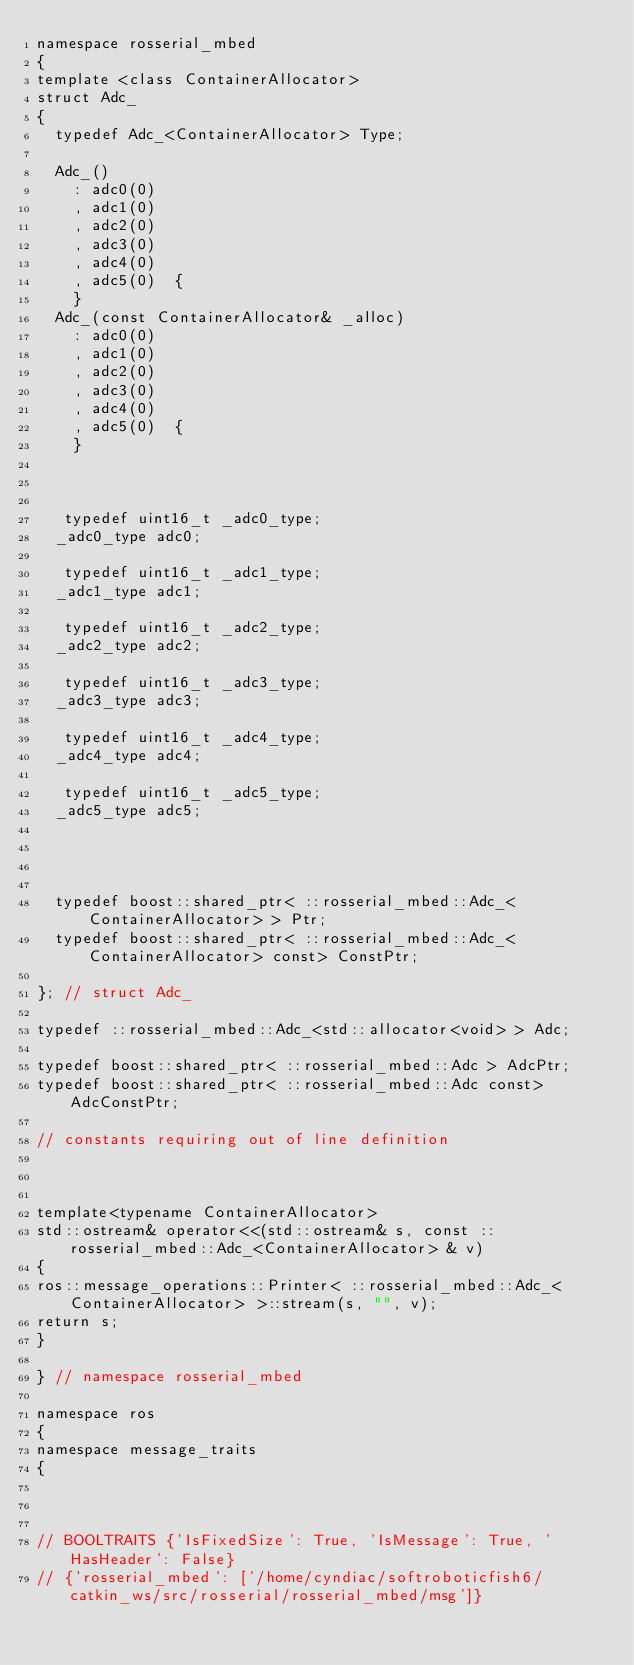Convert code to text. <code><loc_0><loc_0><loc_500><loc_500><_C_>namespace rosserial_mbed
{
template <class ContainerAllocator>
struct Adc_
{
  typedef Adc_<ContainerAllocator> Type;

  Adc_()
    : adc0(0)
    , adc1(0)
    , adc2(0)
    , adc3(0)
    , adc4(0)
    , adc5(0)  {
    }
  Adc_(const ContainerAllocator& _alloc)
    : adc0(0)
    , adc1(0)
    , adc2(0)
    , adc3(0)
    , adc4(0)
    , adc5(0)  {
    }



   typedef uint16_t _adc0_type;
  _adc0_type adc0;

   typedef uint16_t _adc1_type;
  _adc1_type adc1;

   typedef uint16_t _adc2_type;
  _adc2_type adc2;

   typedef uint16_t _adc3_type;
  _adc3_type adc3;

   typedef uint16_t _adc4_type;
  _adc4_type adc4;

   typedef uint16_t _adc5_type;
  _adc5_type adc5;




  typedef boost::shared_ptr< ::rosserial_mbed::Adc_<ContainerAllocator> > Ptr;
  typedef boost::shared_ptr< ::rosserial_mbed::Adc_<ContainerAllocator> const> ConstPtr;

}; // struct Adc_

typedef ::rosserial_mbed::Adc_<std::allocator<void> > Adc;

typedef boost::shared_ptr< ::rosserial_mbed::Adc > AdcPtr;
typedef boost::shared_ptr< ::rosserial_mbed::Adc const> AdcConstPtr;

// constants requiring out of line definition



template<typename ContainerAllocator>
std::ostream& operator<<(std::ostream& s, const ::rosserial_mbed::Adc_<ContainerAllocator> & v)
{
ros::message_operations::Printer< ::rosserial_mbed::Adc_<ContainerAllocator> >::stream(s, "", v);
return s;
}

} // namespace rosserial_mbed

namespace ros
{
namespace message_traits
{



// BOOLTRAITS {'IsFixedSize': True, 'IsMessage': True, 'HasHeader': False}
// {'rosserial_mbed': ['/home/cyndiac/softroboticfish6/catkin_ws/src/rosserial/rosserial_mbed/msg']}
</code> 